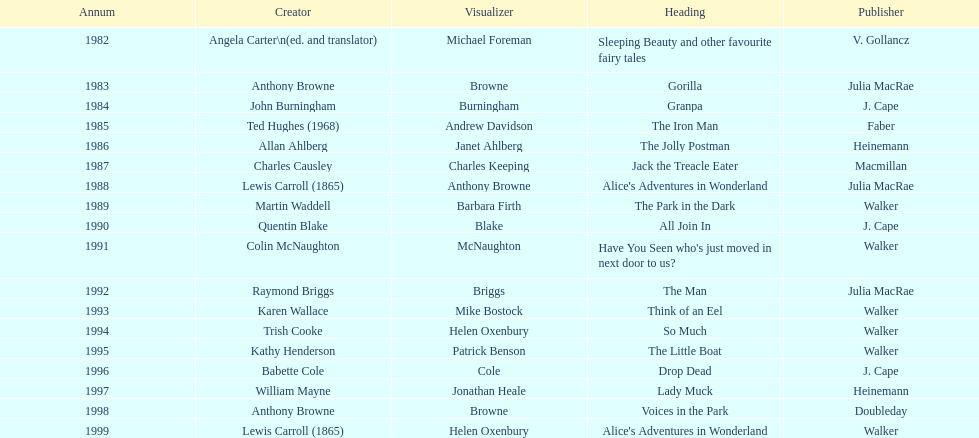Which illustrator was responsible for the last award winner? Helen Oxenbury. 